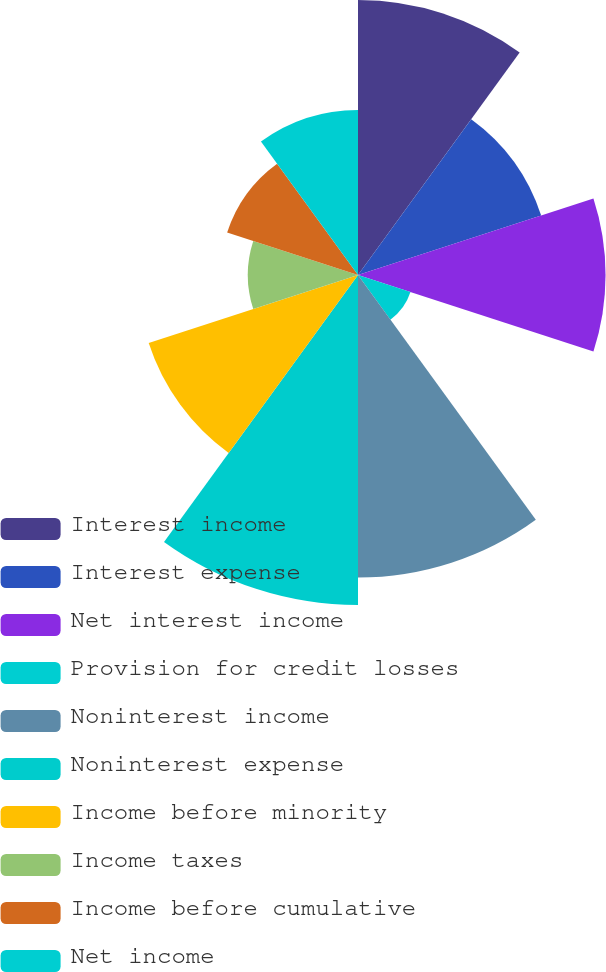Convert chart to OTSL. <chart><loc_0><loc_0><loc_500><loc_500><pie_chart><fcel>Interest income<fcel>Interest expense<fcel>Net interest income<fcel>Provision for credit losses<fcel>Noninterest income<fcel>Noninterest expense<fcel>Income before minority<fcel>Income taxes<fcel>Income before cumulative<fcel>Net income<nl><fcel>13.51%<fcel>9.46%<fcel>12.16%<fcel>2.71%<fcel>14.86%<fcel>16.21%<fcel>10.81%<fcel>5.41%<fcel>6.76%<fcel>8.11%<nl></chart> 